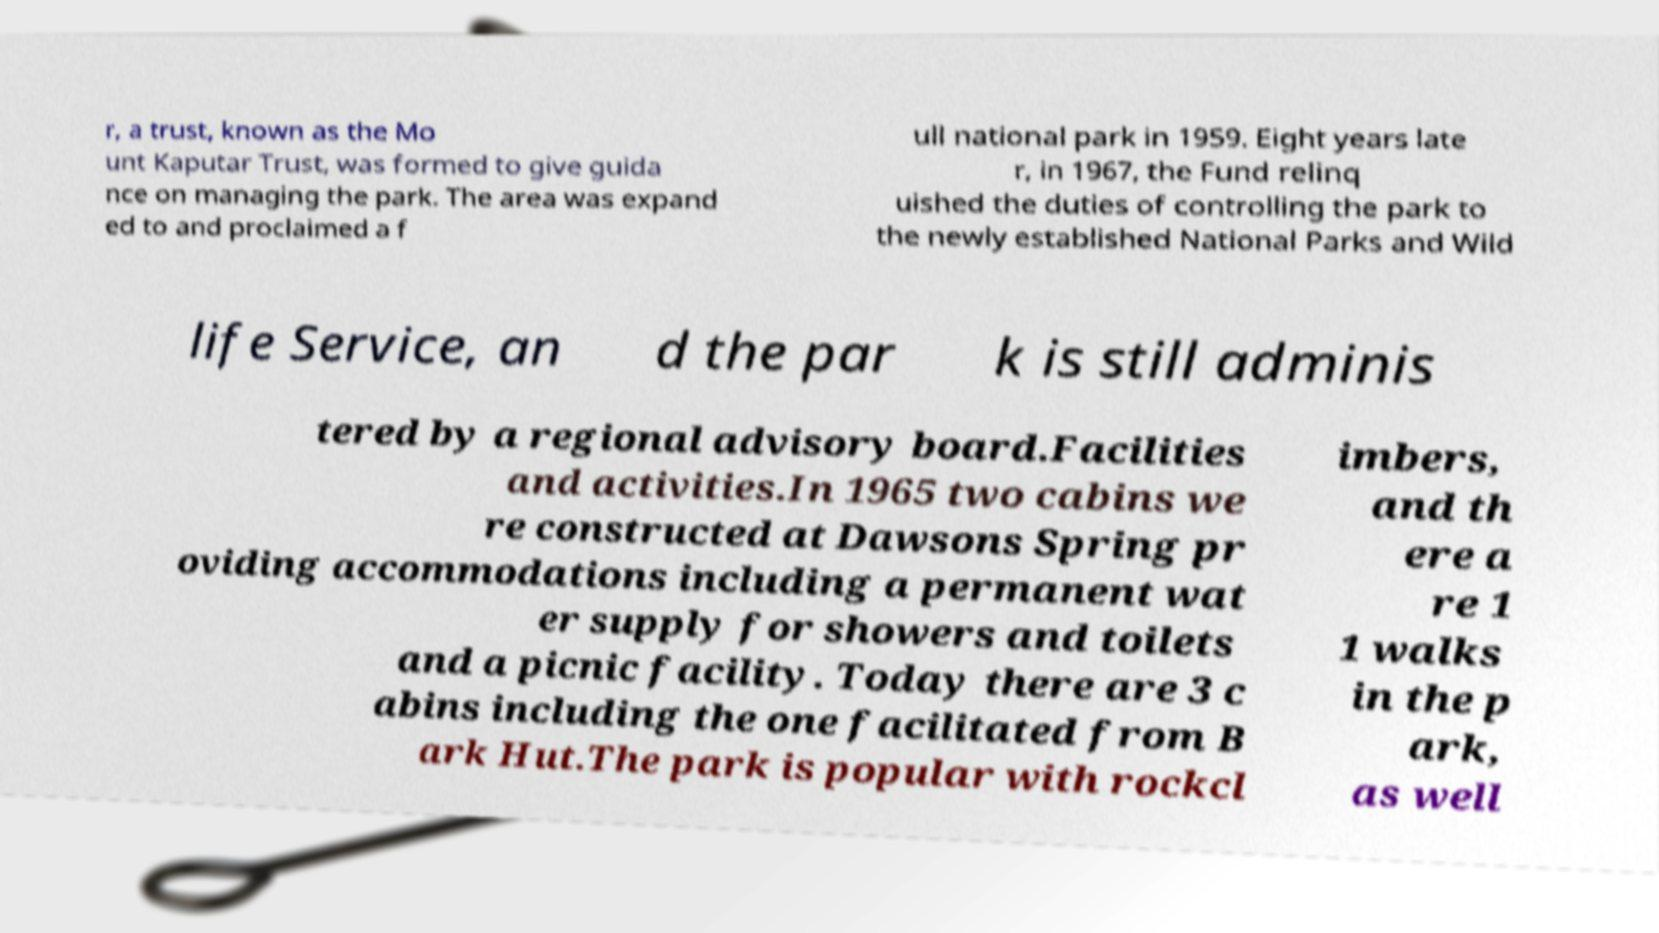Could you assist in decoding the text presented in this image and type it out clearly? r, a trust, known as the Mo unt Kaputar Trust, was formed to give guida nce on managing the park. The area was expand ed to and proclaimed a f ull national park in 1959. Eight years late r, in 1967, the Fund relinq uished the duties of controlling the park to the newly established National Parks and Wild life Service, an d the par k is still adminis tered by a regional advisory board.Facilities and activities.In 1965 two cabins we re constructed at Dawsons Spring pr oviding accommodations including a permanent wat er supply for showers and toilets and a picnic facility. Today there are 3 c abins including the one facilitated from B ark Hut.The park is popular with rockcl imbers, and th ere a re 1 1 walks in the p ark, as well 